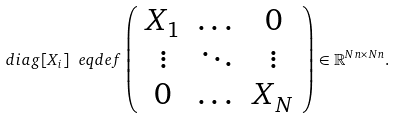<formula> <loc_0><loc_0><loc_500><loc_500>d i a g [ X _ { i } ] \ e q d e f \left ( \begin{array} { c c c } X _ { 1 } & \dots & 0 \\ \vdots & \ddots & \vdots \\ 0 & \dots & X _ { N } \end{array} \right ) \in \mathbb { R } ^ { N n \times N n } .</formula> 